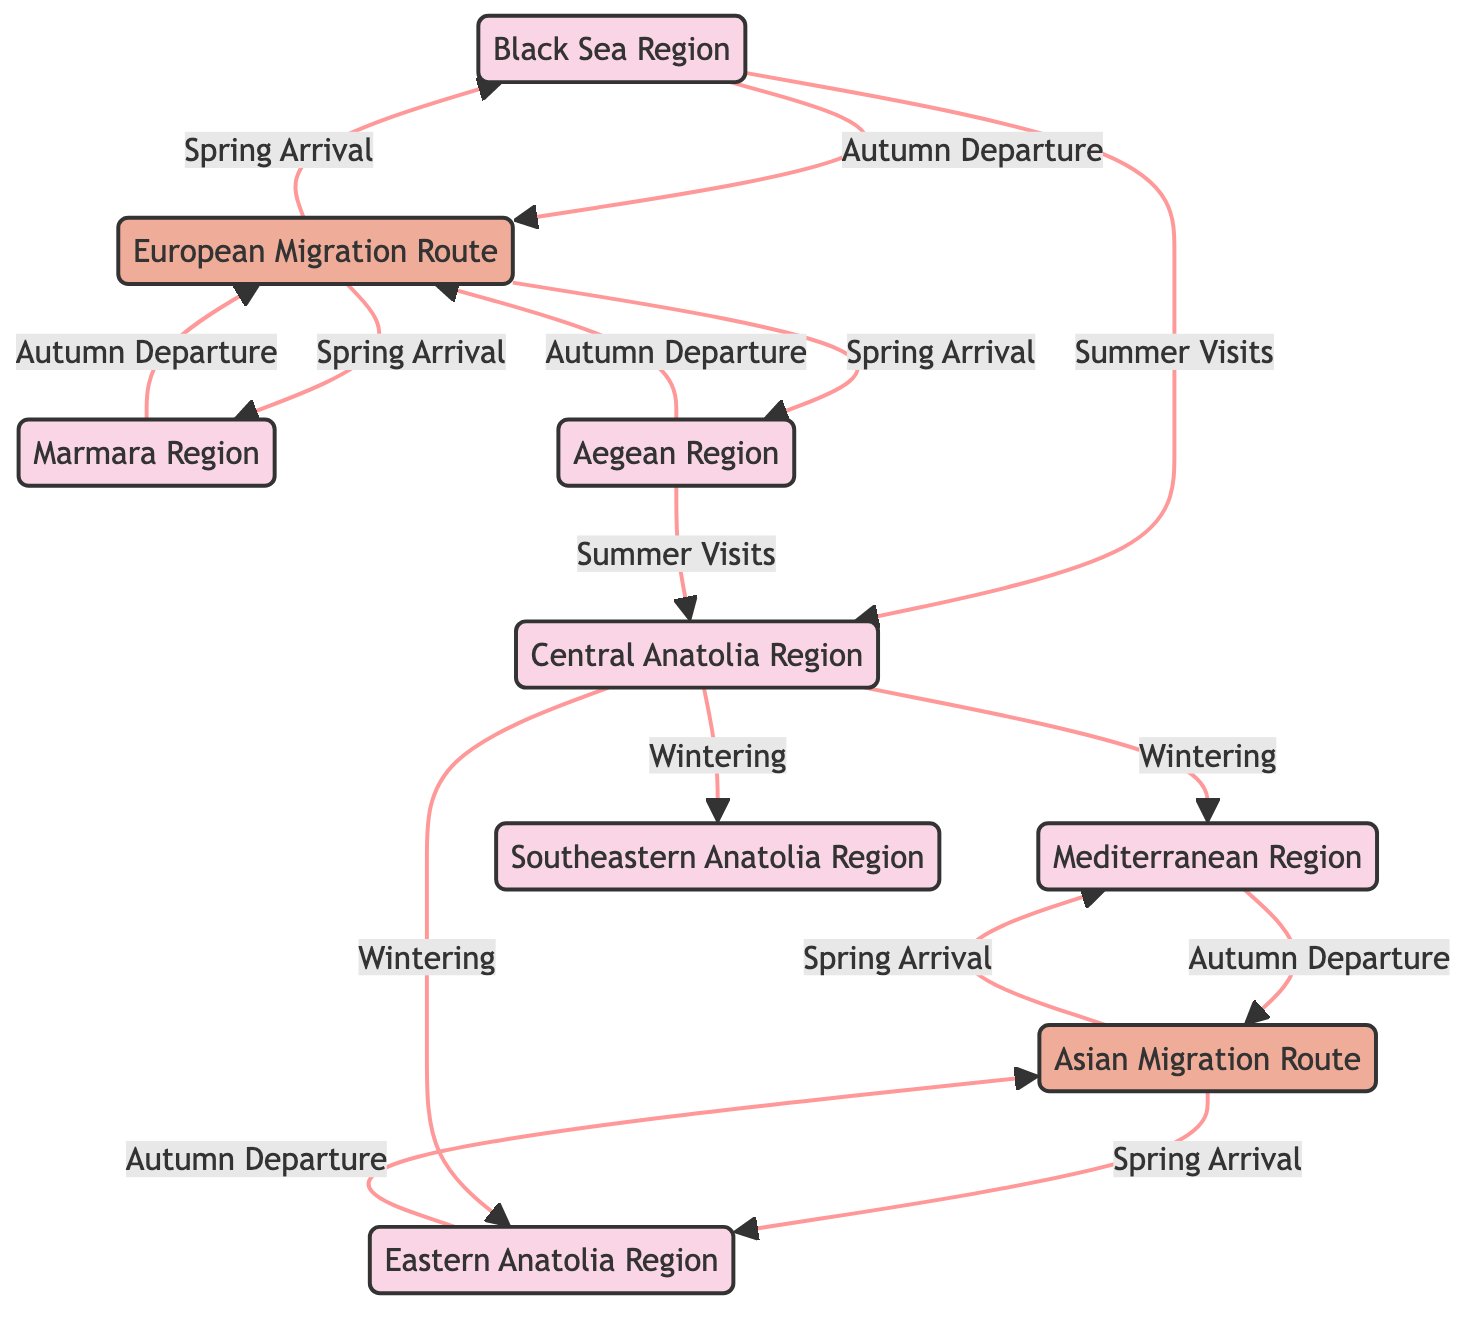What are the two main migration routes depicted in the diagram? The diagram shows the "European Migration Route" and the "Asian Migration Route" as the two main routes for seasonal bird migration.
Answer: European Migration Route, Asian Migration Route How many regions in Turkey are connected to the European Migration Route during spring? The European Migration Route connects with 3 regions: Black Sea Region, Marmara Region, and Aegean Region during the spring arrival of birds.
Answer: 3 Which region do birds depart from during autumn migration towards the Asian Migration Route? According to the diagram, birds depart from the Mediterranean Region and Eastern Anatolia Region towards the Asian Migration Route in autumn.
Answer: Mediterranean Region, Eastern Anatolia Region What type of visits does the Central Anatolia Region receive during summer? The Central Anatolia Region is visited by birds during summer, as indicated in the diagram, specifically from the Black Sea Region and Aegean Region.
Answer: Summer Visits During which season do birds winter in both the Mediterranean Region and Southeastern Anatolia Region? The diagram specifies that birds winter in both the Mediterranean Region and Southeastern Anatolia Region, suggesting the winter season for these regions.
Answer: Winter What is the relationship between the Black Sea Region and the Autumn Departure route? The Black Sea Region is one of the regions where birds depart towards the European Migration Route during autumn, indicating a direct connection between them.
Answer: Direct connection How many total regions are depicted in the diagram? The diagram lists a total of 7 regions, which include Black Sea Region, Marmara Region, Aegean Region, Mediterranean Region, Central Anatolia Region, Eastern Anatolia Region, and Southeastern Anatolia Region.
Answer: 7 Which route do the majority of regions connect with during spring? The majority of regions, specifically 3 from the diagram, connect with the European Migration Route during the spring arrival of birds.
Answer: European Migration Route What seasonal behavior is represented by the arrows leading to the Central Anatolia Region? The arrows leading to the Central Anatolia Region represent "Summer Visits," indicating that this region is visited by birds during the summer season.
Answer: Summer Visits 